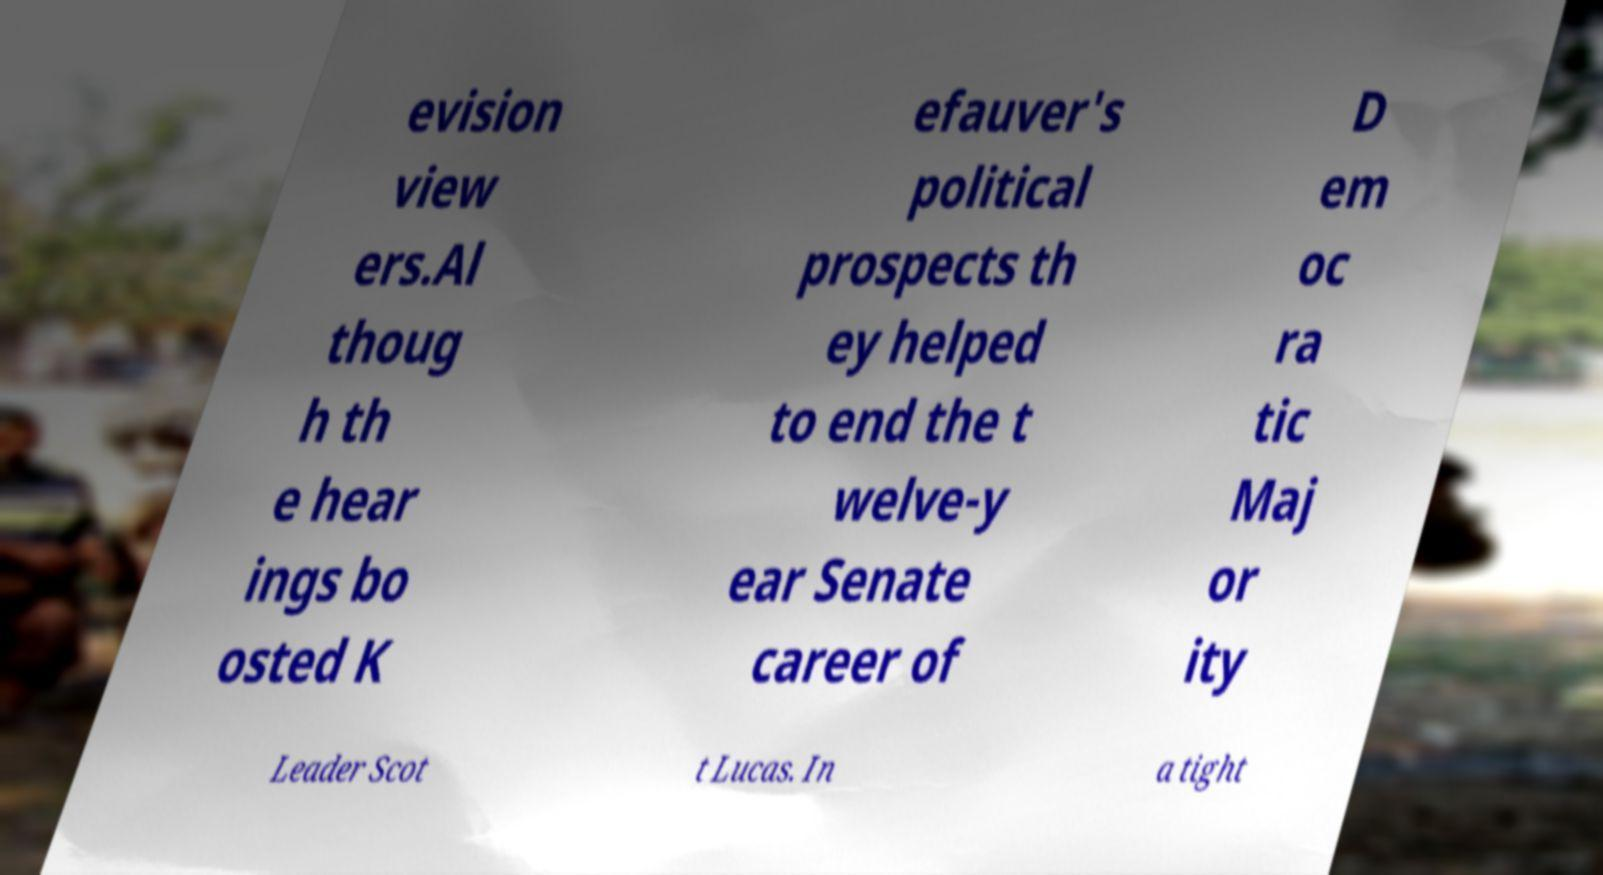There's text embedded in this image that I need extracted. Can you transcribe it verbatim? evision view ers.Al thoug h th e hear ings bo osted K efauver's political prospects th ey helped to end the t welve-y ear Senate career of D em oc ra tic Maj or ity Leader Scot t Lucas. In a tight 